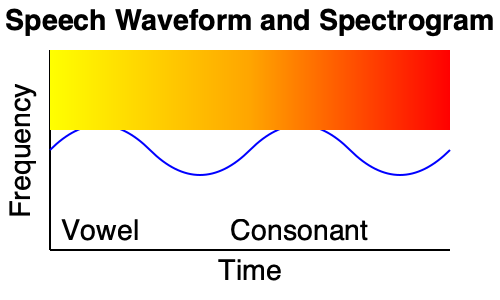Analyze the speech waveform and spectrogram provided. How would the acoustic characteristics differ for a deaf individual attempting to produce the same speech sound, and what visual cues in the diagram could be used to guide their pronunciation? To answer this question, we need to consider several factors:

1. Acoustic characteristics of typical speech:
   - The waveform shows a regular pattern for the vowel and an irregular pattern for the consonant.
   - The spectrogram shows clear formant structures for the vowel (horizontal bands) and vertical striations for the consonant.

2. Differences in deaf speech production:
   - Deaf individuals often have difficulty controlling pitch and intensity due to lack of auditory feedback.
   - They may struggle with timing and duration of sounds, especially in transitions between vowels and consonants.
   - Formant frequencies and their relative intensities might be atypical, affecting vowel quality.

3. Visual cues in the diagram for guiding pronunciation:
   - Waveform amplitude: Indicates the intensity of the sound, which can be used to guide volume control.
   - Waveform regularity: Shows the difference between vowels (regular) and consonants (irregular), helping with timing and articulation.
   - Spectrogram intensity (color): Represents the energy distribution across frequencies, useful for adjusting articulation.
   - Formant structures: Visible as dark bands in the spectrogram, can guide tongue position and shape for vowel production.
   - Consonant transitions: Visible as vertical striations, can help with timing and articulation of consonants.

4. Strategies for deaf individuals:
   - Use visual feedback from waveform displays to practice controlling intensity and duration.
   - Utilize spectrogram displays to refine articulation and achieve target formant frequencies.
   - Practice transitions between sounds by observing changes in both waveform and spectrogram patterns.
   - Focus on maintaining consistent patterns for repeated sounds to improve overall speech consistency.

5. Potential challenges:
   - Difficulty in perceiving and reproducing subtle acoustic differences that are not visually apparent.
   - Overreliance on visual cues may lead to exaggerated or unnatural speech patterns.
   - Individual variations in vocal tract anatomy may require personalized interpretation of visual feedback.

By combining knowledge of typical speech acoustics with an understanding of the challenges faced by deaf speakers, one can use these visual representations to guide and improve pronunciation.
Answer: Deaf speech may show irregular pitch, intensity, and timing; visual cues from waveform amplitude, regularity, and spectrogram patterns can guide pronunciation improvements. 